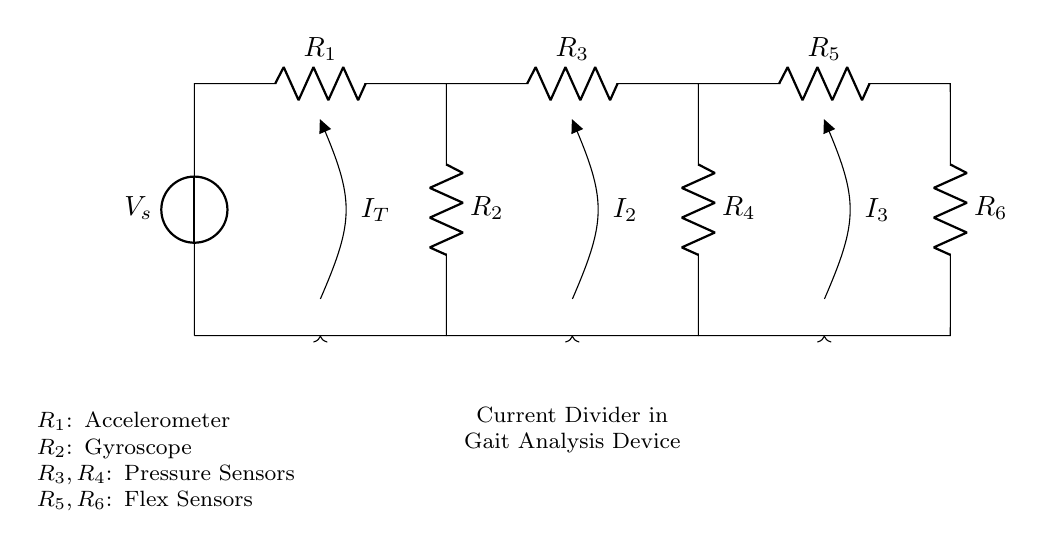What are the components used in this circuit? The circuit contains a voltage source, six resistors representing various sensors (accelerometer, gyroscope, pressure sensors, and flex sensors).
Answer: Voltage source, six resistors What type of circuit is this? This is a multi-branch current divider circuit, which splits the total current into several paths through multiple branches of resistors.
Answer: Current divider What does the current labeled "I_T" represent? "I_T" is the total current supplied by the voltage source, which enters the circuit and then divides among the branches via the resistors.
Answer: Total current How many branches are there in this circuit? The circuit has three branches connected in parallel, each containing a set of resistors.
Answer: Three branches What sensors are represented by resistors R3 and R4? Resistors R3 and R4 represent pressure sensors in the gait analysis device.
Answer: Pressure sensors If the total resistance is reduced, what happens to the total current "I_T"? According to Ohm's Law, if the total resistance decreases, the total current "I_T" increases, provided the voltage remains constant.
Answer: Increases Which resistors correspond to the flex sensors? Resistors R5 and R6 correspond to the flex sensors in the circuit.
Answer: R5 and R6 